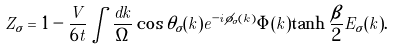Convert formula to latex. <formula><loc_0><loc_0><loc_500><loc_500>Z _ { \sigma } = 1 - \frac { V } { 6 t } \int \frac { d k } { \Omega } \cos \theta _ { \sigma } ( k ) e ^ { - i \phi _ { \sigma } ( k ) } \Phi ( k ) \tanh \frac { \beta } { 2 } E _ { \sigma } ( k ) .</formula> 